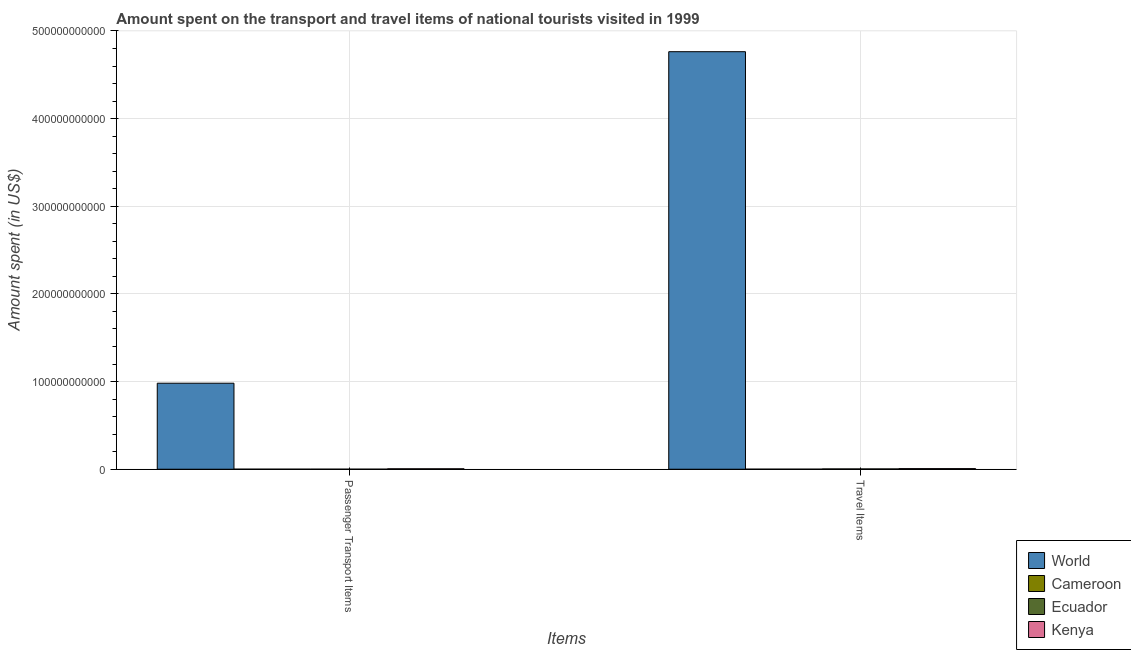How many different coloured bars are there?
Provide a short and direct response. 4. Are the number of bars per tick equal to the number of legend labels?
Your answer should be very brief. Yes. What is the label of the 1st group of bars from the left?
Your answer should be very brief. Passenger Transport Items. What is the amount spent on passenger transport items in Cameroon?
Make the answer very short. 3.20e+07. Across all countries, what is the maximum amount spent in travel items?
Your answer should be compact. 4.76e+11. Across all countries, what is the minimum amount spent on passenger transport items?
Ensure brevity in your answer.  3.20e+07. In which country was the amount spent on passenger transport items minimum?
Your answer should be compact. Cameroon. What is the total amount spent on passenger transport items in the graph?
Your answer should be compact. 9.87e+1. What is the difference between the amount spent on passenger transport items in Kenya and that in World?
Ensure brevity in your answer.  -9.76e+1. What is the difference between the amount spent in travel items in Ecuador and the amount spent on passenger transport items in Cameroon?
Offer a very short reply. 3.11e+08. What is the average amount spent in travel items per country?
Make the answer very short. 1.19e+11. What is the difference between the amount spent on passenger transport items and amount spent in travel items in Cameroon?
Offer a very short reply. -2.80e+07. In how many countries, is the amount spent in travel items greater than 380000000000 US$?
Provide a short and direct response. 1. What is the ratio of the amount spent on passenger transport items in Ecuador to that in World?
Your answer should be compact. 0. In how many countries, is the amount spent in travel items greater than the average amount spent in travel items taken over all countries?
Give a very brief answer. 1. What does the 1st bar from the left in Travel Items represents?
Give a very brief answer. World. What does the 1st bar from the right in Passenger Transport Items represents?
Give a very brief answer. Kenya. How many bars are there?
Your answer should be compact. 8. Are all the bars in the graph horizontal?
Your answer should be compact. No. How many countries are there in the graph?
Your answer should be very brief. 4. What is the difference between two consecutive major ticks on the Y-axis?
Keep it short and to the point. 1.00e+11. Are the values on the major ticks of Y-axis written in scientific E-notation?
Make the answer very short. No. Does the graph contain grids?
Offer a terse response. Yes. What is the title of the graph?
Offer a very short reply. Amount spent on the transport and travel items of national tourists visited in 1999. Does "Samoa" appear as one of the legend labels in the graph?
Keep it short and to the point. No. What is the label or title of the X-axis?
Provide a short and direct response. Items. What is the label or title of the Y-axis?
Provide a short and direct response. Amount spent (in US$). What is the Amount spent (in US$) in World in Passenger Transport Items?
Your answer should be very brief. 9.81e+1. What is the Amount spent (in US$) of Cameroon in Passenger Transport Items?
Give a very brief answer. 3.20e+07. What is the Amount spent (in US$) of Ecuador in Passenger Transport Items?
Your answer should be very brief. 3.40e+07. What is the Amount spent (in US$) of Kenya in Passenger Transport Items?
Make the answer very short. 5.06e+08. What is the Amount spent (in US$) in World in Travel Items?
Give a very brief answer. 4.76e+11. What is the Amount spent (in US$) of Cameroon in Travel Items?
Keep it short and to the point. 6.00e+07. What is the Amount spent (in US$) of Ecuador in Travel Items?
Provide a succinct answer. 3.43e+08. What is the Amount spent (in US$) in Kenya in Travel Items?
Your response must be concise. 7.05e+08. Across all Items, what is the maximum Amount spent (in US$) of World?
Your response must be concise. 4.76e+11. Across all Items, what is the maximum Amount spent (in US$) of Cameroon?
Provide a succinct answer. 6.00e+07. Across all Items, what is the maximum Amount spent (in US$) in Ecuador?
Offer a very short reply. 3.43e+08. Across all Items, what is the maximum Amount spent (in US$) in Kenya?
Offer a terse response. 7.05e+08. Across all Items, what is the minimum Amount spent (in US$) in World?
Offer a terse response. 9.81e+1. Across all Items, what is the minimum Amount spent (in US$) of Cameroon?
Ensure brevity in your answer.  3.20e+07. Across all Items, what is the minimum Amount spent (in US$) in Ecuador?
Offer a very short reply. 3.40e+07. Across all Items, what is the minimum Amount spent (in US$) of Kenya?
Your answer should be compact. 5.06e+08. What is the total Amount spent (in US$) in World in the graph?
Provide a short and direct response. 5.74e+11. What is the total Amount spent (in US$) in Cameroon in the graph?
Offer a terse response. 9.20e+07. What is the total Amount spent (in US$) in Ecuador in the graph?
Offer a terse response. 3.77e+08. What is the total Amount spent (in US$) in Kenya in the graph?
Ensure brevity in your answer.  1.21e+09. What is the difference between the Amount spent (in US$) of World in Passenger Transport Items and that in Travel Items?
Provide a short and direct response. -3.78e+11. What is the difference between the Amount spent (in US$) in Cameroon in Passenger Transport Items and that in Travel Items?
Your answer should be very brief. -2.80e+07. What is the difference between the Amount spent (in US$) in Ecuador in Passenger Transport Items and that in Travel Items?
Your answer should be compact. -3.09e+08. What is the difference between the Amount spent (in US$) of Kenya in Passenger Transport Items and that in Travel Items?
Make the answer very short. -1.99e+08. What is the difference between the Amount spent (in US$) in World in Passenger Transport Items and the Amount spent (in US$) in Cameroon in Travel Items?
Your answer should be very brief. 9.81e+1. What is the difference between the Amount spent (in US$) of World in Passenger Transport Items and the Amount spent (in US$) of Ecuador in Travel Items?
Keep it short and to the point. 9.78e+1. What is the difference between the Amount spent (in US$) of World in Passenger Transport Items and the Amount spent (in US$) of Kenya in Travel Items?
Offer a terse response. 9.74e+1. What is the difference between the Amount spent (in US$) in Cameroon in Passenger Transport Items and the Amount spent (in US$) in Ecuador in Travel Items?
Offer a very short reply. -3.11e+08. What is the difference between the Amount spent (in US$) in Cameroon in Passenger Transport Items and the Amount spent (in US$) in Kenya in Travel Items?
Your answer should be very brief. -6.73e+08. What is the difference between the Amount spent (in US$) in Ecuador in Passenger Transport Items and the Amount spent (in US$) in Kenya in Travel Items?
Provide a succinct answer. -6.71e+08. What is the average Amount spent (in US$) in World per Items?
Your answer should be very brief. 2.87e+11. What is the average Amount spent (in US$) in Cameroon per Items?
Keep it short and to the point. 4.60e+07. What is the average Amount spent (in US$) in Ecuador per Items?
Provide a succinct answer. 1.88e+08. What is the average Amount spent (in US$) of Kenya per Items?
Keep it short and to the point. 6.06e+08. What is the difference between the Amount spent (in US$) in World and Amount spent (in US$) in Cameroon in Passenger Transport Items?
Offer a very short reply. 9.81e+1. What is the difference between the Amount spent (in US$) in World and Amount spent (in US$) in Ecuador in Passenger Transport Items?
Make the answer very short. 9.81e+1. What is the difference between the Amount spent (in US$) of World and Amount spent (in US$) of Kenya in Passenger Transport Items?
Your response must be concise. 9.76e+1. What is the difference between the Amount spent (in US$) of Cameroon and Amount spent (in US$) of Ecuador in Passenger Transport Items?
Provide a short and direct response. -2.00e+06. What is the difference between the Amount spent (in US$) of Cameroon and Amount spent (in US$) of Kenya in Passenger Transport Items?
Give a very brief answer. -4.74e+08. What is the difference between the Amount spent (in US$) of Ecuador and Amount spent (in US$) of Kenya in Passenger Transport Items?
Keep it short and to the point. -4.72e+08. What is the difference between the Amount spent (in US$) of World and Amount spent (in US$) of Cameroon in Travel Items?
Make the answer very short. 4.76e+11. What is the difference between the Amount spent (in US$) in World and Amount spent (in US$) in Ecuador in Travel Items?
Keep it short and to the point. 4.76e+11. What is the difference between the Amount spent (in US$) of World and Amount spent (in US$) of Kenya in Travel Items?
Make the answer very short. 4.76e+11. What is the difference between the Amount spent (in US$) in Cameroon and Amount spent (in US$) in Ecuador in Travel Items?
Your answer should be very brief. -2.83e+08. What is the difference between the Amount spent (in US$) of Cameroon and Amount spent (in US$) of Kenya in Travel Items?
Give a very brief answer. -6.45e+08. What is the difference between the Amount spent (in US$) of Ecuador and Amount spent (in US$) of Kenya in Travel Items?
Your answer should be compact. -3.62e+08. What is the ratio of the Amount spent (in US$) in World in Passenger Transport Items to that in Travel Items?
Provide a succinct answer. 0.21. What is the ratio of the Amount spent (in US$) in Cameroon in Passenger Transport Items to that in Travel Items?
Offer a very short reply. 0.53. What is the ratio of the Amount spent (in US$) in Ecuador in Passenger Transport Items to that in Travel Items?
Give a very brief answer. 0.1. What is the ratio of the Amount spent (in US$) of Kenya in Passenger Transport Items to that in Travel Items?
Provide a succinct answer. 0.72. What is the difference between the highest and the second highest Amount spent (in US$) in World?
Give a very brief answer. 3.78e+11. What is the difference between the highest and the second highest Amount spent (in US$) in Cameroon?
Make the answer very short. 2.80e+07. What is the difference between the highest and the second highest Amount spent (in US$) in Ecuador?
Provide a succinct answer. 3.09e+08. What is the difference between the highest and the second highest Amount spent (in US$) of Kenya?
Your answer should be compact. 1.99e+08. What is the difference between the highest and the lowest Amount spent (in US$) in World?
Keep it short and to the point. 3.78e+11. What is the difference between the highest and the lowest Amount spent (in US$) in Cameroon?
Ensure brevity in your answer.  2.80e+07. What is the difference between the highest and the lowest Amount spent (in US$) in Ecuador?
Keep it short and to the point. 3.09e+08. What is the difference between the highest and the lowest Amount spent (in US$) of Kenya?
Provide a short and direct response. 1.99e+08. 